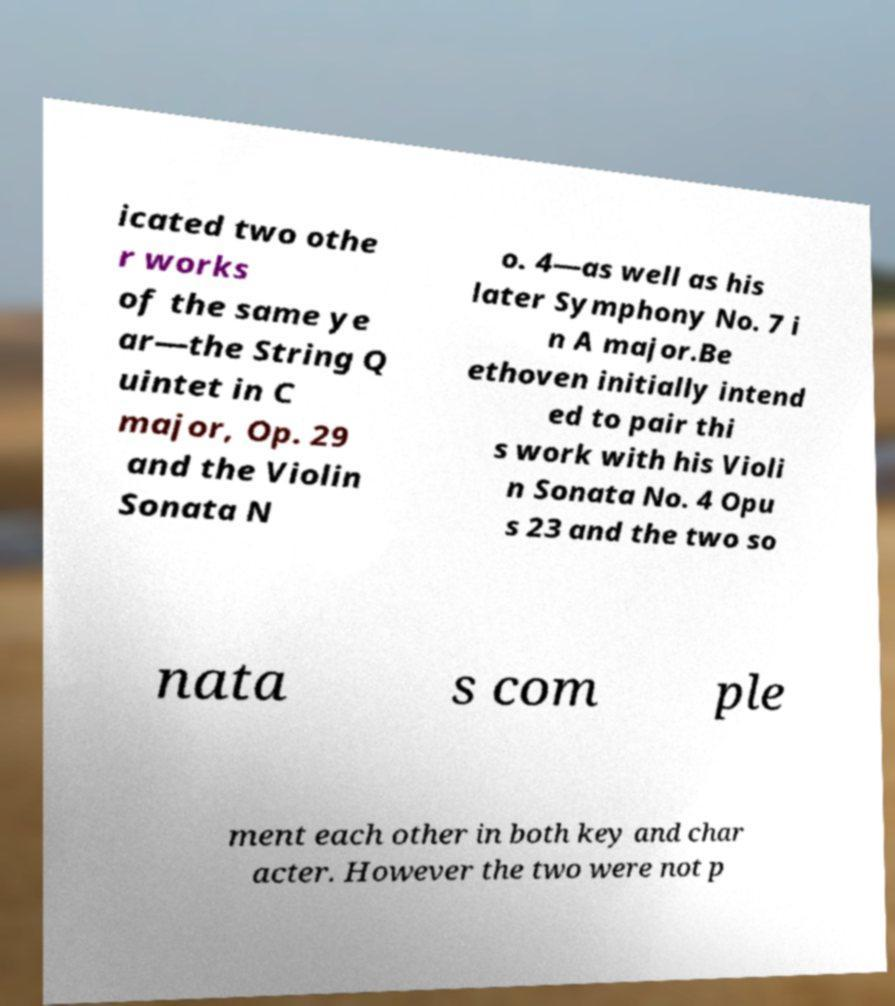Can you accurately transcribe the text from the provided image for me? icated two othe r works of the same ye ar—the String Q uintet in C major, Op. 29 and the Violin Sonata N o. 4—as well as his later Symphony No. 7 i n A major.Be ethoven initially intend ed to pair thi s work with his Violi n Sonata No. 4 Opu s 23 and the two so nata s com ple ment each other in both key and char acter. However the two were not p 